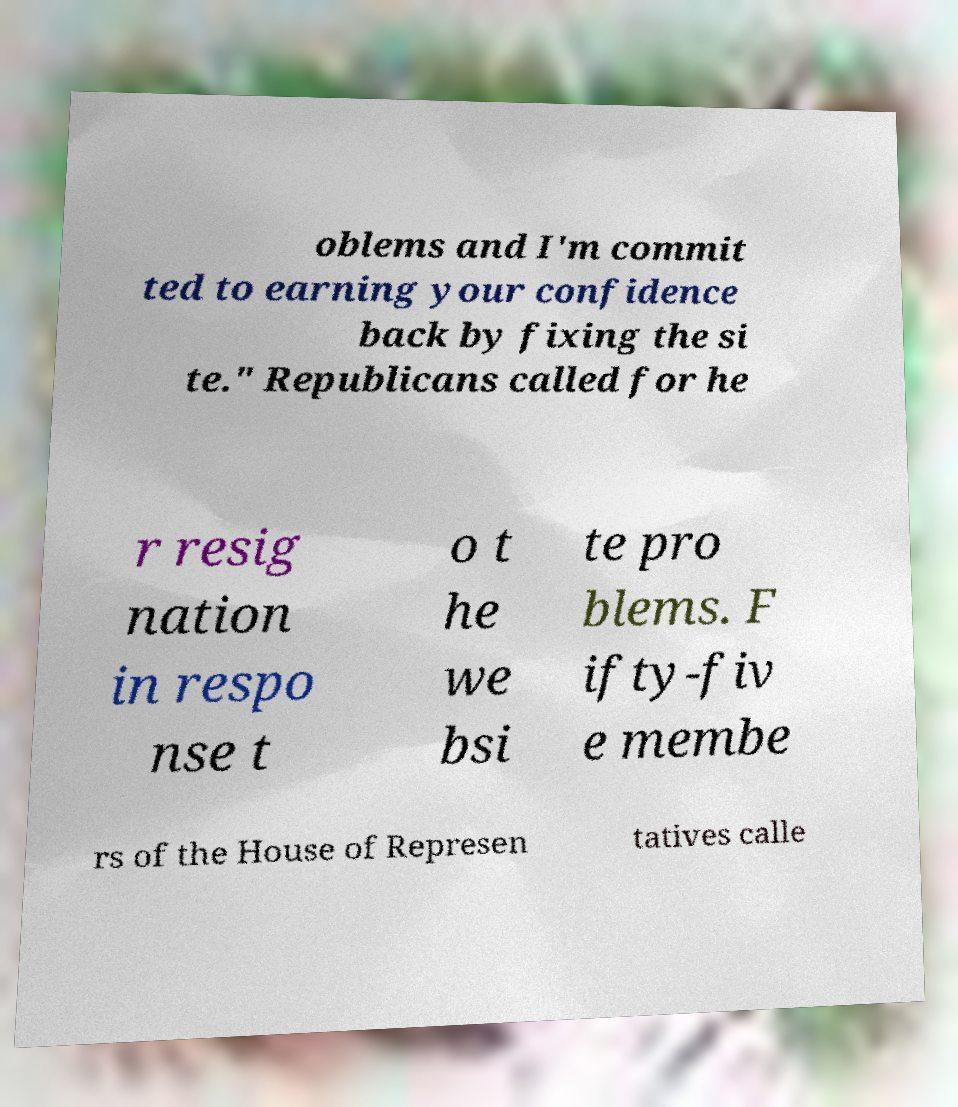For documentation purposes, I need the text within this image transcribed. Could you provide that? oblems and I'm commit ted to earning your confidence back by fixing the si te." Republicans called for he r resig nation in respo nse t o t he we bsi te pro blems. F ifty-fiv e membe rs of the House of Represen tatives calle 